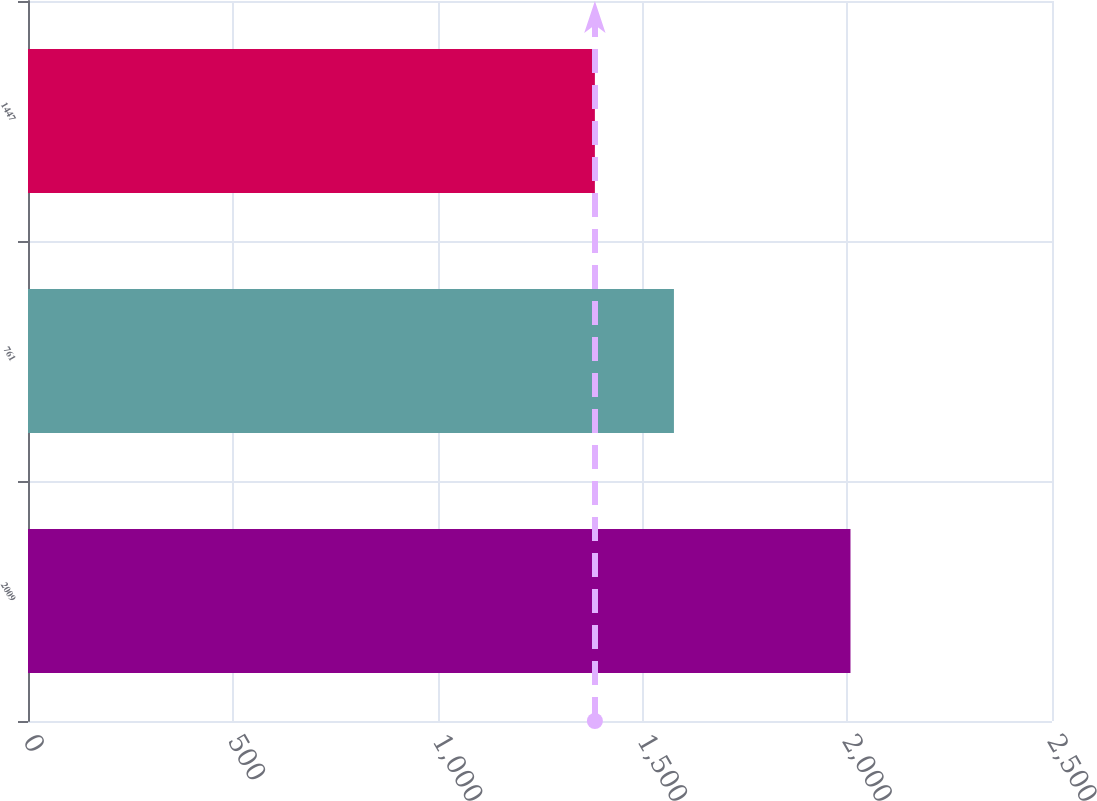Convert chart. <chart><loc_0><loc_0><loc_500><loc_500><bar_chart><fcel>2009<fcel>761<fcel>1447<nl><fcel>2008<fcel>1577<fcel>1384<nl></chart> 